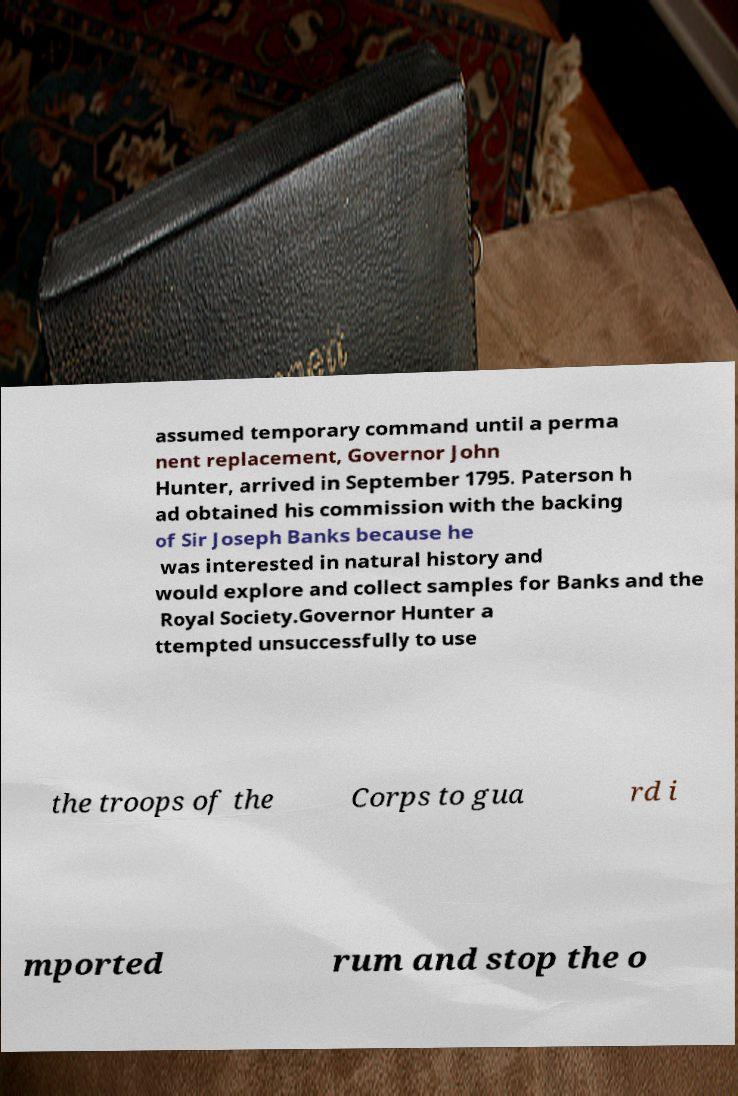Could you assist in decoding the text presented in this image and type it out clearly? assumed temporary command until a perma nent replacement, Governor John Hunter, arrived in September 1795. Paterson h ad obtained his commission with the backing of Sir Joseph Banks because he was interested in natural history and would explore and collect samples for Banks and the Royal Society.Governor Hunter a ttempted unsuccessfully to use the troops of the Corps to gua rd i mported rum and stop the o 